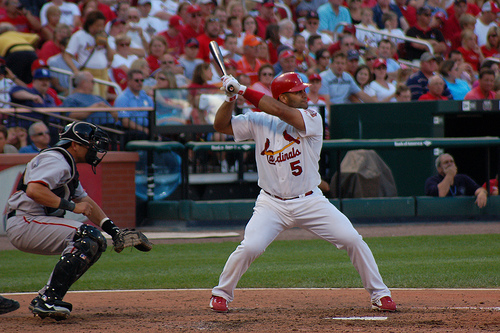What team is the batter playing for? The batter is wearing a uniform with 'Cardinals' written on it, indicating he is playing for the St. Louis Cardinals. 